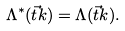Convert formula to latex. <formula><loc_0><loc_0><loc_500><loc_500>\Lambda ^ { * } ( \vec { t } k ) = \Lambda ( \vec { t } k ) .</formula> 